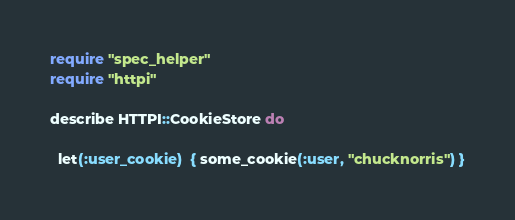<code> <loc_0><loc_0><loc_500><loc_500><_Ruby_>require "spec_helper"
require "httpi"

describe HTTPI::CookieStore do

  let(:user_cookie)  { some_cookie(:user, "chucknorris") }</code> 